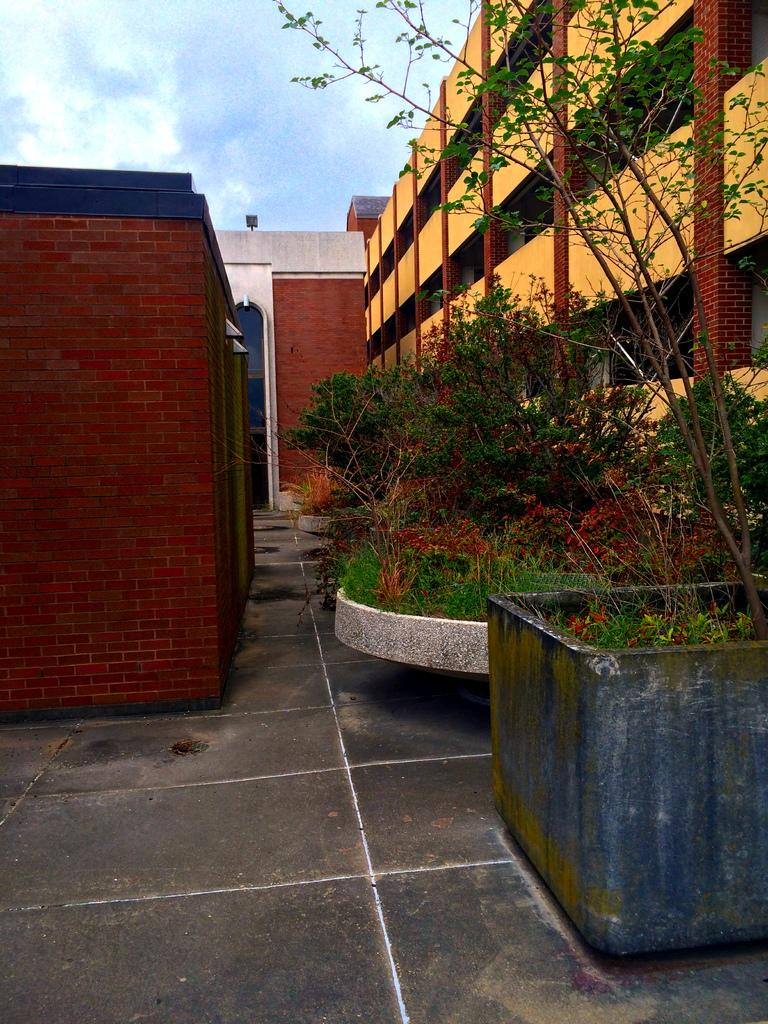What type of structure is present in the image? There is a building in the image. What other elements can be seen in the image besides the building? There are plants in the image. Can you describe the surroundings of the building and plants? There are other unspecified things around the building and plants. Where is the trail leading to in the image? There is no trail present in the image. 